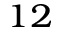<formula> <loc_0><loc_0><loc_500><loc_500>_ { 1 2 }</formula> 